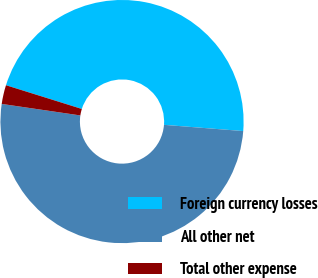<chart> <loc_0><loc_0><loc_500><loc_500><pie_chart><fcel>Foreign currency losses<fcel>All other net<fcel>Total other expense<nl><fcel>46.42%<fcel>51.07%<fcel>2.51%<nl></chart> 